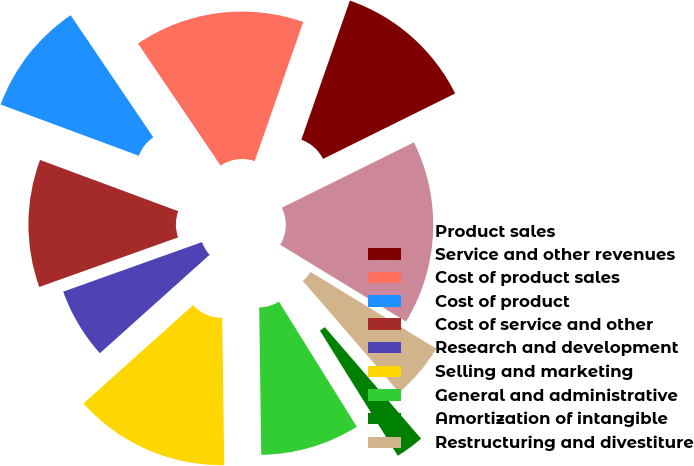Convert chart to OTSL. <chart><loc_0><loc_0><loc_500><loc_500><pie_chart><fcel>Product sales<fcel>Service and other revenues<fcel>Cost of product sales<fcel>Cost of product<fcel>Cost of service and other<fcel>Research and development<fcel>Selling and marketing<fcel>General and administrative<fcel>Amortization of intangible<fcel>Restructuring and divestiture<nl><fcel>16.04%<fcel>12.34%<fcel>14.81%<fcel>9.88%<fcel>11.11%<fcel>6.18%<fcel>13.58%<fcel>8.64%<fcel>2.48%<fcel>4.94%<nl></chart> 